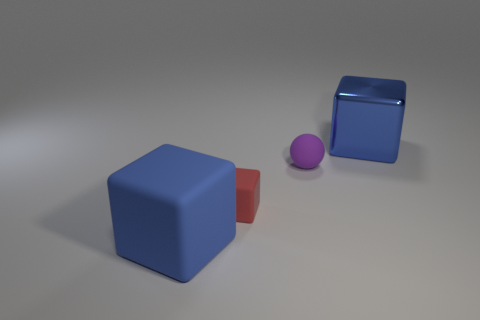Add 1 red rubber cubes. How many objects exist? 5 Subtract all spheres. How many objects are left? 3 Add 1 matte balls. How many matte balls are left? 2 Add 3 blue cylinders. How many blue cylinders exist? 3 Subtract 0 yellow cylinders. How many objects are left? 4 Subtract all small cubes. Subtract all tiny red things. How many objects are left? 2 